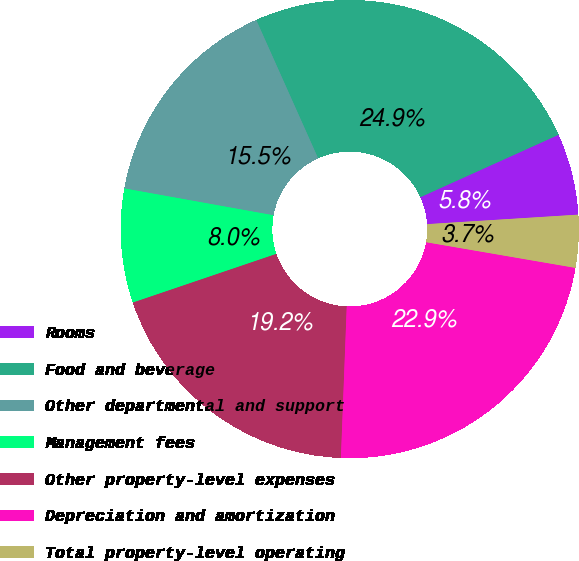Convert chart to OTSL. <chart><loc_0><loc_0><loc_500><loc_500><pie_chart><fcel>Rooms<fcel>Food and beverage<fcel>Other departmental and support<fcel>Management fees<fcel>Other property-level expenses<fcel>Depreciation and amortization<fcel>Total property-level operating<nl><fcel>5.75%<fcel>24.94%<fcel>15.47%<fcel>8.04%<fcel>19.18%<fcel>22.9%<fcel>3.71%<nl></chart> 